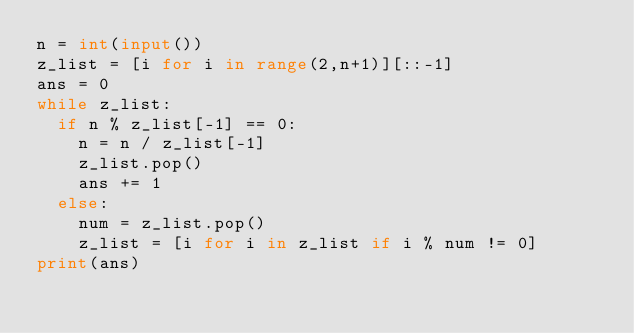Convert code to text. <code><loc_0><loc_0><loc_500><loc_500><_Python_>n = int(input())
z_list = [i for i in range(2,n+1)][::-1]
ans = 0
while z_list:
  if n % z_list[-1] == 0:
    n = n / z_list[-1]
    z_list.pop()
    ans += 1
  else:
    num = z_list.pop()
    z_list = [i for i in z_list if i % num != 0]
print(ans)</code> 